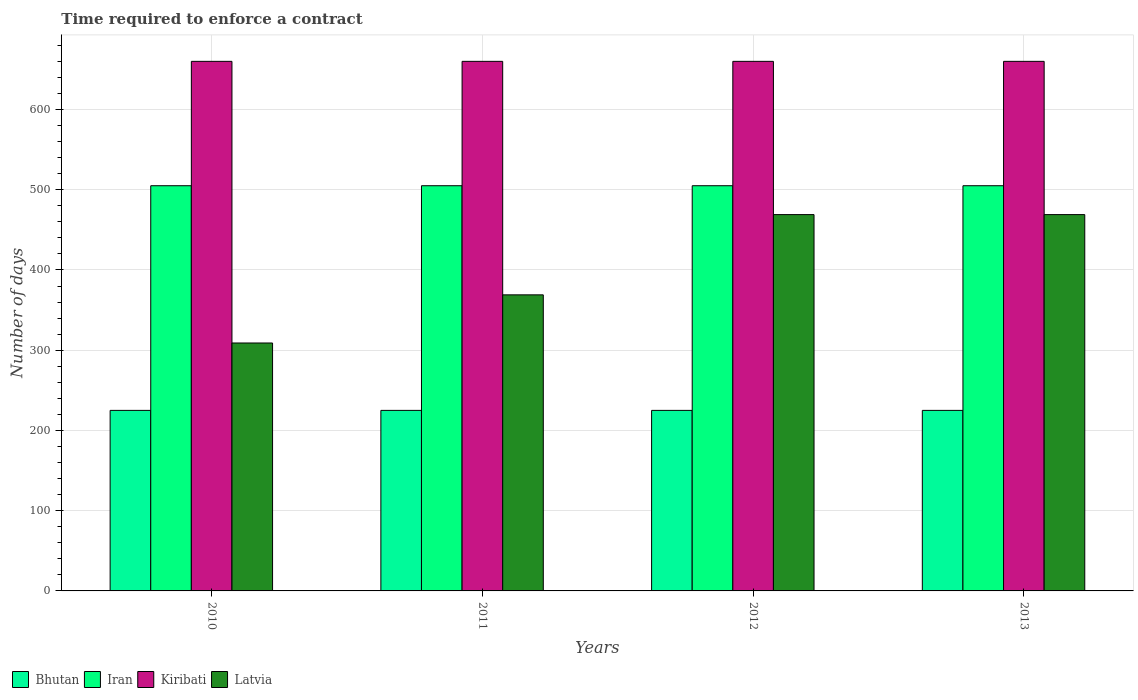How many groups of bars are there?
Your answer should be compact. 4. How many bars are there on the 1st tick from the left?
Offer a terse response. 4. In how many cases, is the number of bars for a given year not equal to the number of legend labels?
Make the answer very short. 0. What is the number of days required to enforce a contract in Latvia in 2012?
Keep it short and to the point. 469. Across all years, what is the maximum number of days required to enforce a contract in Kiribati?
Your response must be concise. 660. Across all years, what is the minimum number of days required to enforce a contract in Latvia?
Give a very brief answer. 309. In which year was the number of days required to enforce a contract in Bhutan minimum?
Ensure brevity in your answer.  2010. What is the total number of days required to enforce a contract in Latvia in the graph?
Your answer should be compact. 1616. What is the difference between the number of days required to enforce a contract in Kiribati in 2011 and the number of days required to enforce a contract in Bhutan in 2013?
Offer a very short reply. 435. What is the average number of days required to enforce a contract in Kiribati per year?
Ensure brevity in your answer.  660. In the year 2013, what is the difference between the number of days required to enforce a contract in Kiribati and number of days required to enforce a contract in Latvia?
Offer a terse response. 191. Is the difference between the number of days required to enforce a contract in Kiribati in 2010 and 2013 greater than the difference between the number of days required to enforce a contract in Latvia in 2010 and 2013?
Your answer should be very brief. Yes. What is the difference between the highest and the lowest number of days required to enforce a contract in Latvia?
Ensure brevity in your answer.  160. What does the 2nd bar from the left in 2012 represents?
Ensure brevity in your answer.  Iran. What does the 1st bar from the right in 2013 represents?
Keep it short and to the point. Latvia. Does the graph contain any zero values?
Offer a terse response. No. Does the graph contain grids?
Provide a succinct answer. Yes. Where does the legend appear in the graph?
Provide a succinct answer. Bottom left. How many legend labels are there?
Provide a short and direct response. 4. How are the legend labels stacked?
Offer a terse response. Horizontal. What is the title of the graph?
Offer a terse response. Time required to enforce a contract. What is the label or title of the X-axis?
Your response must be concise. Years. What is the label or title of the Y-axis?
Your answer should be compact. Number of days. What is the Number of days in Bhutan in 2010?
Give a very brief answer. 225. What is the Number of days in Iran in 2010?
Offer a terse response. 505. What is the Number of days of Kiribati in 2010?
Your answer should be very brief. 660. What is the Number of days of Latvia in 2010?
Provide a succinct answer. 309. What is the Number of days in Bhutan in 2011?
Make the answer very short. 225. What is the Number of days in Iran in 2011?
Offer a very short reply. 505. What is the Number of days of Kiribati in 2011?
Give a very brief answer. 660. What is the Number of days of Latvia in 2011?
Provide a succinct answer. 369. What is the Number of days of Bhutan in 2012?
Give a very brief answer. 225. What is the Number of days in Iran in 2012?
Provide a short and direct response. 505. What is the Number of days in Kiribati in 2012?
Your answer should be compact. 660. What is the Number of days of Latvia in 2012?
Your answer should be compact. 469. What is the Number of days of Bhutan in 2013?
Provide a short and direct response. 225. What is the Number of days of Iran in 2013?
Your answer should be compact. 505. What is the Number of days in Kiribati in 2013?
Ensure brevity in your answer.  660. What is the Number of days of Latvia in 2013?
Make the answer very short. 469. Across all years, what is the maximum Number of days of Bhutan?
Keep it short and to the point. 225. Across all years, what is the maximum Number of days in Iran?
Give a very brief answer. 505. Across all years, what is the maximum Number of days of Kiribati?
Your answer should be compact. 660. Across all years, what is the maximum Number of days in Latvia?
Ensure brevity in your answer.  469. Across all years, what is the minimum Number of days in Bhutan?
Give a very brief answer. 225. Across all years, what is the minimum Number of days in Iran?
Offer a terse response. 505. Across all years, what is the minimum Number of days in Kiribati?
Ensure brevity in your answer.  660. Across all years, what is the minimum Number of days of Latvia?
Give a very brief answer. 309. What is the total Number of days in Bhutan in the graph?
Your answer should be very brief. 900. What is the total Number of days in Iran in the graph?
Keep it short and to the point. 2020. What is the total Number of days in Kiribati in the graph?
Your answer should be compact. 2640. What is the total Number of days in Latvia in the graph?
Give a very brief answer. 1616. What is the difference between the Number of days in Kiribati in 2010 and that in 2011?
Your response must be concise. 0. What is the difference between the Number of days of Latvia in 2010 and that in 2011?
Your answer should be compact. -60. What is the difference between the Number of days of Kiribati in 2010 and that in 2012?
Ensure brevity in your answer.  0. What is the difference between the Number of days of Latvia in 2010 and that in 2012?
Ensure brevity in your answer.  -160. What is the difference between the Number of days in Bhutan in 2010 and that in 2013?
Provide a short and direct response. 0. What is the difference between the Number of days in Latvia in 2010 and that in 2013?
Ensure brevity in your answer.  -160. What is the difference between the Number of days of Bhutan in 2011 and that in 2012?
Offer a terse response. 0. What is the difference between the Number of days of Kiribati in 2011 and that in 2012?
Give a very brief answer. 0. What is the difference between the Number of days of Latvia in 2011 and that in 2012?
Provide a succinct answer. -100. What is the difference between the Number of days of Bhutan in 2011 and that in 2013?
Give a very brief answer. 0. What is the difference between the Number of days of Iran in 2011 and that in 2013?
Your answer should be compact. 0. What is the difference between the Number of days of Latvia in 2011 and that in 2013?
Provide a short and direct response. -100. What is the difference between the Number of days of Latvia in 2012 and that in 2013?
Your response must be concise. 0. What is the difference between the Number of days of Bhutan in 2010 and the Number of days of Iran in 2011?
Provide a short and direct response. -280. What is the difference between the Number of days in Bhutan in 2010 and the Number of days in Kiribati in 2011?
Provide a succinct answer. -435. What is the difference between the Number of days of Bhutan in 2010 and the Number of days of Latvia in 2011?
Give a very brief answer. -144. What is the difference between the Number of days of Iran in 2010 and the Number of days of Kiribati in 2011?
Give a very brief answer. -155. What is the difference between the Number of days in Iran in 2010 and the Number of days in Latvia in 2011?
Offer a terse response. 136. What is the difference between the Number of days in Kiribati in 2010 and the Number of days in Latvia in 2011?
Your answer should be compact. 291. What is the difference between the Number of days in Bhutan in 2010 and the Number of days in Iran in 2012?
Offer a very short reply. -280. What is the difference between the Number of days of Bhutan in 2010 and the Number of days of Kiribati in 2012?
Ensure brevity in your answer.  -435. What is the difference between the Number of days in Bhutan in 2010 and the Number of days in Latvia in 2012?
Keep it short and to the point. -244. What is the difference between the Number of days in Iran in 2010 and the Number of days in Kiribati in 2012?
Provide a short and direct response. -155. What is the difference between the Number of days in Iran in 2010 and the Number of days in Latvia in 2012?
Keep it short and to the point. 36. What is the difference between the Number of days in Kiribati in 2010 and the Number of days in Latvia in 2012?
Make the answer very short. 191. What is the difference between the Number of days in Bhutan in 2010 and the Number of days in Iran in 2013?
Your answer should be very brief. -280. What is the difference between the Number of days in Bhutan in 2010 and the Number of days in Kiribati in 2013?
Make the answer very short. -435. What is the difference between the Number of days of Bhutan in 2010 and the Number of days of Latvia in 2013?
Your answer should be compact. -244. What is the difference between the Number of days in Iran in 2010 and the Number of days in Kiribati in 2013?
Provide a short and direct response. -155. What is the difference between the Number of days in Iran in 2010 and the Number of days in Latvia in 2013?
Keep it short and to the point. 36. What is the difference between the Number of days in Kiribati in 2010 and the Number of days in Latvia in 2013?
Your answer should be very brief. 191. What is the difference between the Number of days in Bhutan in 2011 and the Number of days in Iran in 2012?
Provide a short and direct response. -280. What is the difference between the Number of days of Bhutan in 2011 and the Number of days of Kiribati in 2012?
Give a very brief answer. -435. What is the difference between the Number of days of Bhutan in 2011 and the Number of days of Latvia in 2012?
Your response must be concise. -244. What is the difference between the Number of days in Iran in 2011 and the Number of days in Kiribati in 2012?
Your answer should be very brief. -155. What is the difference between the Number of days of Kiribati in 2011 and the Number of days of Latvia in 2012?
Give a very brief answer. 191. What is the difference between the Number of days of Bhutan in 2011 and the Number of days of Iran in 2013?
Your answer should be very brief. -280. What is the difference between the Number of days of Bhutan in 2011 and the Number of days of Kiribati in 2013?
Provide a succinct answer. -435. What is the difference between the Number of days of Bhutan in 2011 and the Number of days of Latvia in 2013?
Your answer should be very brief. -244. What is the difference between the Number of days of Iran in 2011 and the Number of days of Kiribati in 2013?
Make the answer very short. -155. What is the difference between the Number of days in Iran in 2011 and the Number of days in Latvia in 2013?
Provide a short and direct response. 36. What is the difference between the Number of days of Kiribati in 2011 and the Number of days of Latvia in 2013?
Offer a terse response. 191. What is the difference between the Number of days in Bhutan in 2012 and the Number of days in Iran in 2013?
Keep it short and to the point. -280. What is the difference between the Number of days of Bhutan in 2012 and the Number of days of Kiribati in 2013?
Offer a very short reply. -435. What is the difference between the Number of days in Bhutan in 2012 and the Number of days in Latvia in 2013?
Your answer should be compact. -244. What is the difference between the Number of days of Iran in 2012 and the Number of days of Kiribati in 2013?
Your answer should be compact. -155. What is the difference between the Number of days of Iran in 2012 and the Number of days of Latvia in 2013?
Give a very brief answer. 36. What is the difference between the Number of days in Kiribati in 2012 and the Number of days in Latvia in 2013?
Your answer should be very brief. 191. What is the average Number of days of Bhutan per year?
Provide a short and direct response. 225. What is the average Number of days of Iran per year?
Your answer should be very brief. 505. What is the average Number of days of Kiribati per year?
Offer a terse response. 660. What is the average Number of days in Latvia per year?
Provide a short and direct response. 404. In the year 2010, what is the difference between the Number of days of Bhutan and Number of days of Iran?
Provide a succinct answer. -280. In the year 2010, what is the difference between the Number of days of Bhutan and Number of days of Kiribati?
Your response must be concise. -435. In the year 2010, what is the difference between the Number of days in Bhutan and Number of days in Latvia?
Give a very brief answer. -84. In the year 2010, what is the difference between the Number of days of Iran and Number of days of Kiribati?
Keep it short and to the point. -155. In the year 2010, what is the difference between the Number of days in Iran and Number of days in Latvia?
Ensure brevity in your answer.  196. In the year 2010, what is the difference between the Number of days of Kiribati and Number of days of Latvia?
Give a very brief answer. 351. In the year 2011, what is the difference between the Number of days in Bhutan and Number of days in Iran?
Offer a very short reply. -280. In the year 2011, what is the difference between the Number of days of Bhutan and Number of days of Kiribati?
Your response must be concise. -435. In the year 2011, what is the difference between the Number of days of Bhutan and Number of days of Latvia?
Your answer should be compact. -144. In the year 2011, what is the difference between the Number of days in Iran and Number of days in Kiribati?
Your answer should be compact. -155. In the year 2011, what is the difference between the Number of days of Iran and Number of days of Latvia?
Your response must be concise. 136. In the year 2011, what is the difference between the Number of days in Kiribati and Number of days in Latvia?
Your response must be concise. 291. In the year 2012, what is the difference between the Number of days in Bhutan and Number of days in Iran?
Make the answer very short. -280. In the year 2012, what is the difference between the Number of days in Bhutan and Number of days in Kiribati?
Keep it short and to the point. -435. In the year 2012, what is the difference between the Number of days of Bhutan and Number of days of Latvia?
Your response must be concise. -244. In the year 2012, what is the difference between the Number of days in Iran and Number of days in Kiribati?
Provide a short and direct response. -155. In the year 2012, what is the difference between the Number of days of Kiribati and Number of days of Latvia?
Offer a terse response. 191. In the year 2013, what is the difference between the Number of days in Bhutan and Number of days in Iran?
Keep it short and to the point. -280. In the year 2013, what is the difference between the Number of days in Bhutan and Number of days in Kiribati?
Provide a succinct answer. -435. In the year 2013, what is the difference between the Number of days in Bhutan and Number of days in Latvia?
Your response must be concise. -244. In the year 2013, what is the difference between the Number of days of Iran and Number of days of Kiribati?
Offer a very short reply. -155. In the year 2013, what is the difference between the Number of days in Kiribati and Number of days in Latvia?
Your response must be concise. 191. What is the ratio of the Number of days of Bhutan in 2010 to that in 2011?
Your answer should be very brief. 1. What is the ratio of the Number of days of Iran in 2010 to that in 2011?
Your answer should be compact. 1. What is the ratio of the Number of days in Kiribati in 2010 to that in 2011?
Make the answer very short. 1. What is the ratio of the Number of days in Latvia in 2010 to that in 2011?
Ensure brevity in your answer.  0.84. What is the ratio of the Number of days in Bhutan in 2010 to that in 2012?
Provide a short and direct response. 1. What is the ratio of the Number of days in Iran in 2010 to that in 2012?
Make the answer very short. 1. What is the ratio of the Number of days of Kiribati in 2010 to that in 2012?
Give a very brief answer. 1. What is the ratio of the Number of days in Latvia in 2010 to that in 2012?
Give a very brief answer. 0.66. What is the ratio of the Number of days of Latvia in 2010 to that in 2013?
Your answer should be very brief. 0.66. What is the ratio of the Number of days of Latvia in 2011 to that in 2012?
Provide a short and direct response. 0.79. What is the ratio of the Number of days of Bhutan in 2011 to that in 2013?
Your answer should be compact. 1. What is the ratio of the Number of days in Kiribati in 2011 to that in 2013?
Give a very brief answer. 1. What is the ratio of the Number of days in Latvia in 2011 to that in 2013?
Ensure brevity in your answer.  0.79. What is the ratio of the Number of days of Bhutan in 2012 to that in 2013?
Your answer should be compact. 1. What is the ratio of the Number of days in Iran in 2012 to that in 2013?
Offer a very short reply. 1. What is the ratio of the Number of days in Latvia in 2012 to that in 2013?
Ensure brevity in your answer.  1. What is the difference between the highest and the second highest Number of days of Iran?
Provide a succinct answer. 0. What is the difference between the highest and the lowest Number of days in Bhutan?
Make the answer very short. 0. What is the difference between the highest and the lowest Number of days in Kiribati?
Give a very brief answer. 0. What is the difference between the highest and the lowest Number of days in Latvia?
Keep it short and to the point. 160. 